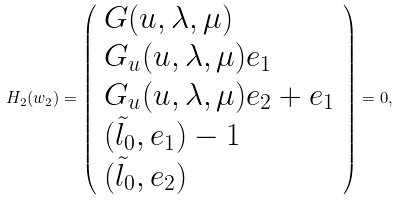<formula> <loc_0><loc_0><loc_500><loc_500>H _ { 2 } ( w _ { 2 } ) = \left ( \begin{array} { l } G ( u , \lambda , \mu ) \\ G _ { u } ( u , \lambda , \mu ) e _ { 1 } \\ G _ { u } ( u , \lambda , \mu ) e _ { 2 } + e _ { 1 } \\ ( \tilde { l } _ { 0 } , e _ { 1 } ) - 1 \\ ( \tilde { l } _ { 0 } , e _ { 2 } ) \end{array} \right ) = 0 ,</formula> 